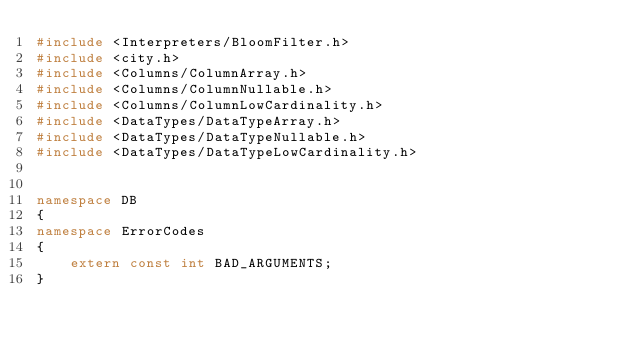<code> <loc_0><loc_0><loc_500><loc_500><_C++_>#include <Interpreters/BloomFilter.h>
#include <city.h>
#include <Columns/ColumnArray.h>
#include <Columns/ColumnNullable.h>
#include <Columns/ColumnLowCardinality.h>
#include <DataTypes/DataTypeArray.h>
#include <DataTypes/DataTypeNullable.h>
#include <DataTypes/DataTypeLowCardinality.h>


namespace DB
{
namespace ErrorCodes
{
    extern const int BAD_ARGUMENTS;
}
</code> 